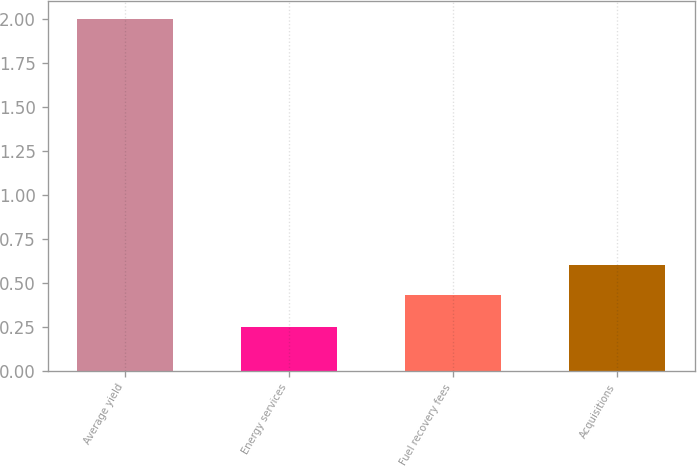<chart> <loc_0><loc_0><loc_500><loc_500><bar_chart><fcel>Average yield<fcel>Energy services<fcel>Fuel recovery fees<fcel>Acquisitions<nl><fcel>2<fcel>0.25<fcel>0.43<fcel>0.6<nl></chart> 